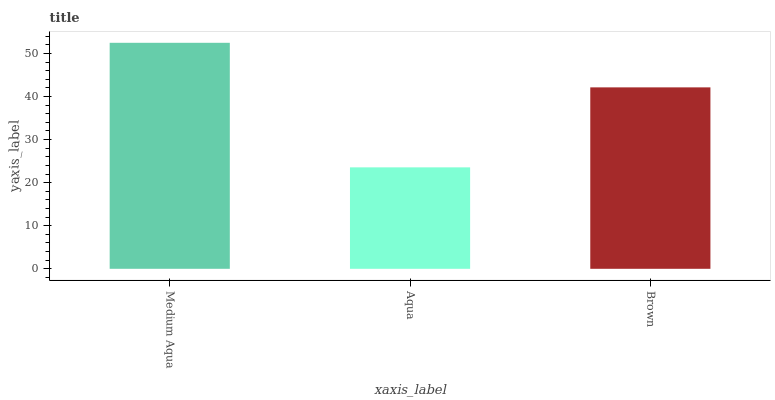Is Brown the minimum?
Answer yes or no. No. Is Brown the maximum?
Answer yes or no. No. Is Brown greater than Aqua?
Answer yes or no. Yes. Is Aqua less than Brown?
Answer yes or no. Yes. Is Aqua greater than Brown?
Answer yes or no. No. Is Brown less than Aqua?
Answer yes or no. No. Is Brown the high median?
Answer yes or no. Yes. Is Brown the low median?
Answer yes or no. Yes. Is Aqua the high median?
Answer yes or no. No. Is Medium Aqua the low median?
Answer yes or no. No. 